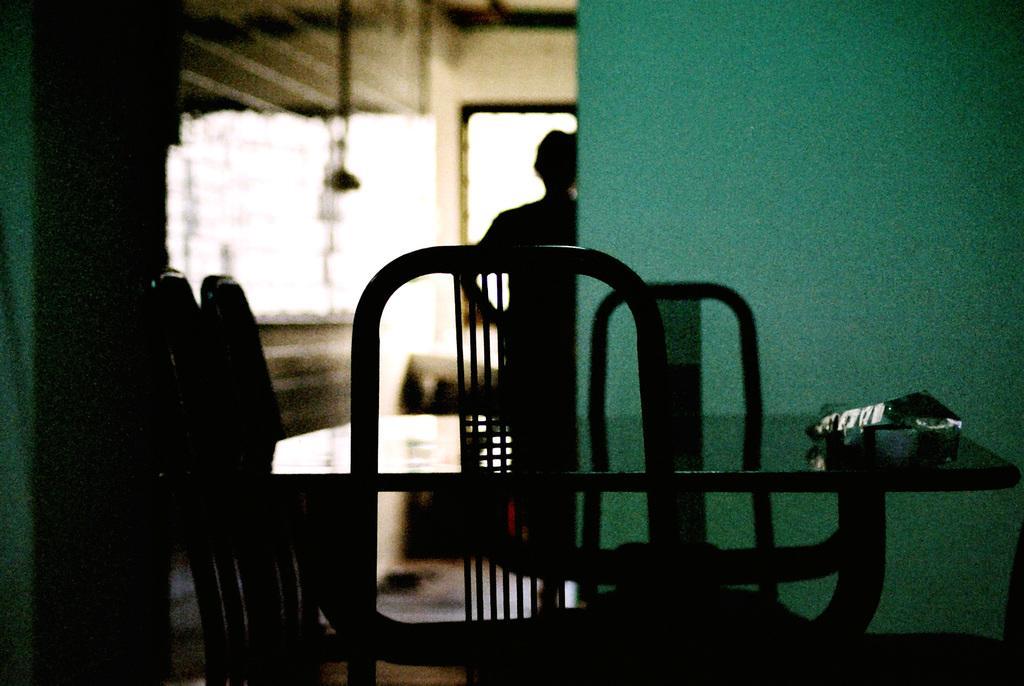Could you give a brief overview of what you see in this image? In the foreground of the image we can see a group of chairs and a table. In the background, we can see a person and a window. 